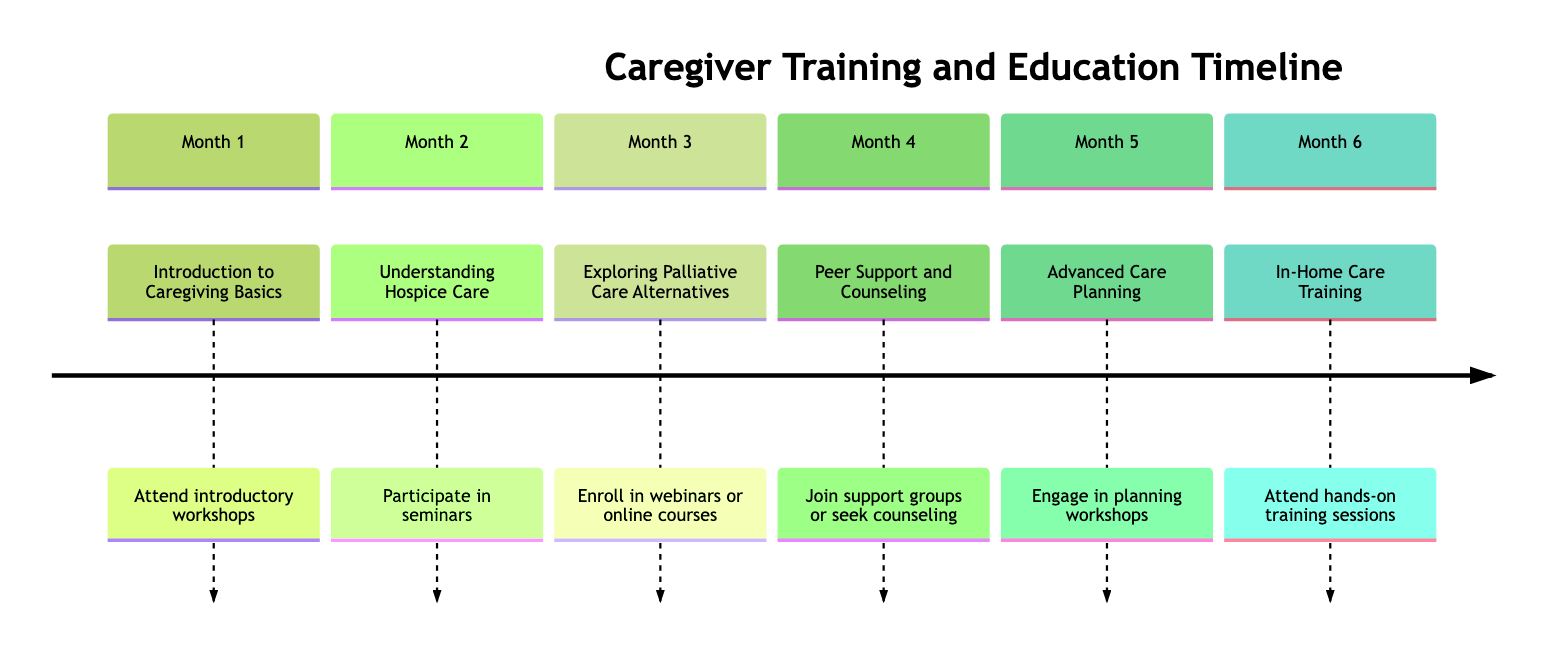What is the title of the third milestone? The third milestone in the timeline is titled "Exploring Palliative Care Alternatives." This can be found by counting down to the third entry in the timeline.
Answer: Exploring Palliative Care Alternatives How many months are covered in the timeline? The timeline lists milestones from Month 1 to Month 6, indicating there are a total of 6 months covered in the timeline.
Answer: 6 What type of workshop is held in Month 5? In Month 5, the type of workshop held is "Advanced Care Planning." This can be identified by looking at the title associated with Month 5 in the timeline.
Answer: Advanced Care Planning Which organization is mentioned for in-home care training? The organization mentioned for in-home care training is "Home Instead Senior Care." This can be determined by checking the description under the sixth milestone.
Answer: Home Instead Senior Care What two types of support are discussed in Month 4? Month 4 discusses "Peer Support and Counseling." The explanation involves looking at the activities listed for Month 4 and recognizing that both peer support and counseling are provided.
Answer: Peer Support and Counseling How many seminars are hosted in Month 2? The timeline states that seminars are participated in during Month 2, but does not specify a number, thus the answer is determined to be "1" as it mentions participation in seminars rather than multiple.
Answer: 1 Which month covers the introduction to caregiving basics? The introduction to caregiving basics is covered in Month 1, according to the description presented for that month in the timeline.
Answer: Month 1 What is the primary focus of webinars listed in Month 3? The primary focus of the webinars listed in Month 3 is "Exploring Palliative Care Alternatives," as stated directly in the description for that milestone.
Answer: Exploring Palliative Care Alternatives What type of training is offered at the end of the timeline? The end of the timeline offers "In-Home Care Training," which is specified in the description under Month 6.
Answer: In-Home Care Training 